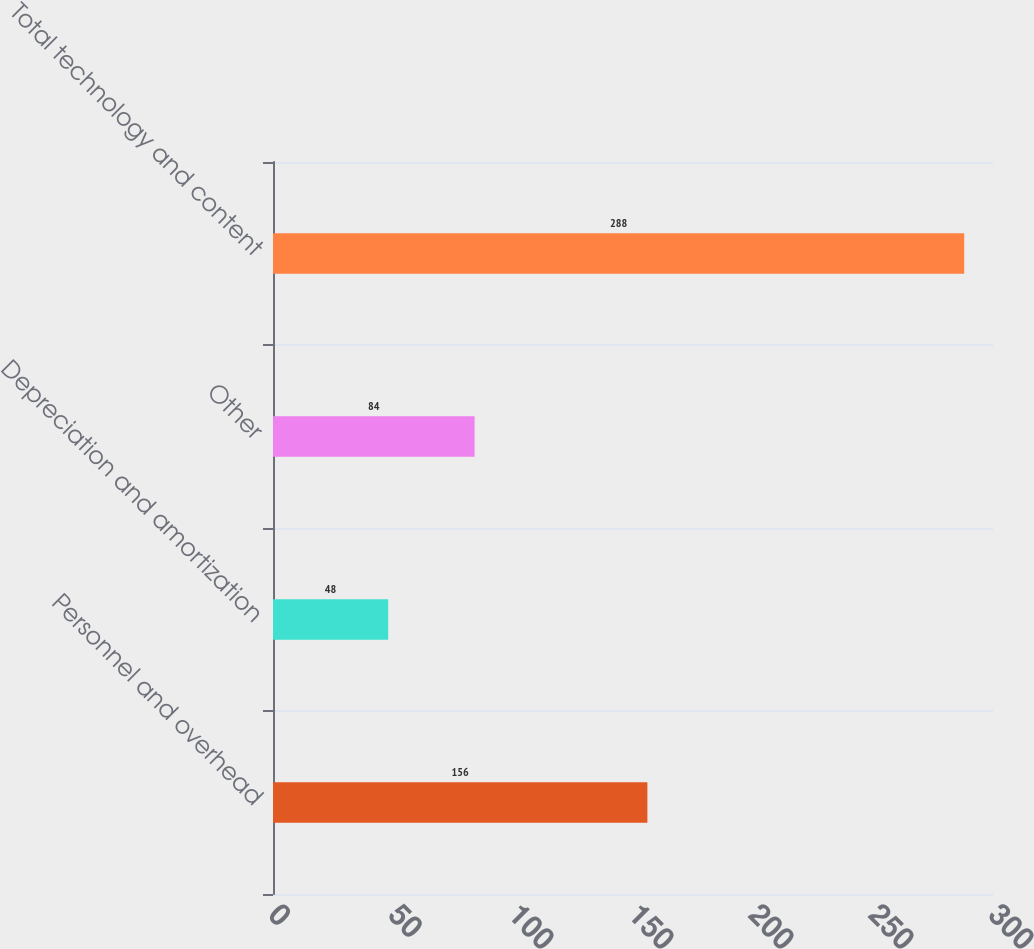Convert chart. <chart><loc_0><loc_0><loc_500><loc_500><bar_chart><fcel>Personnel and overhead<fcel>Depreciation and amortization<fcel>Other<fcel>Total technology and content<nl><fcel>156<fcel>48<fcel>84<fcel>288<nl></chart> 